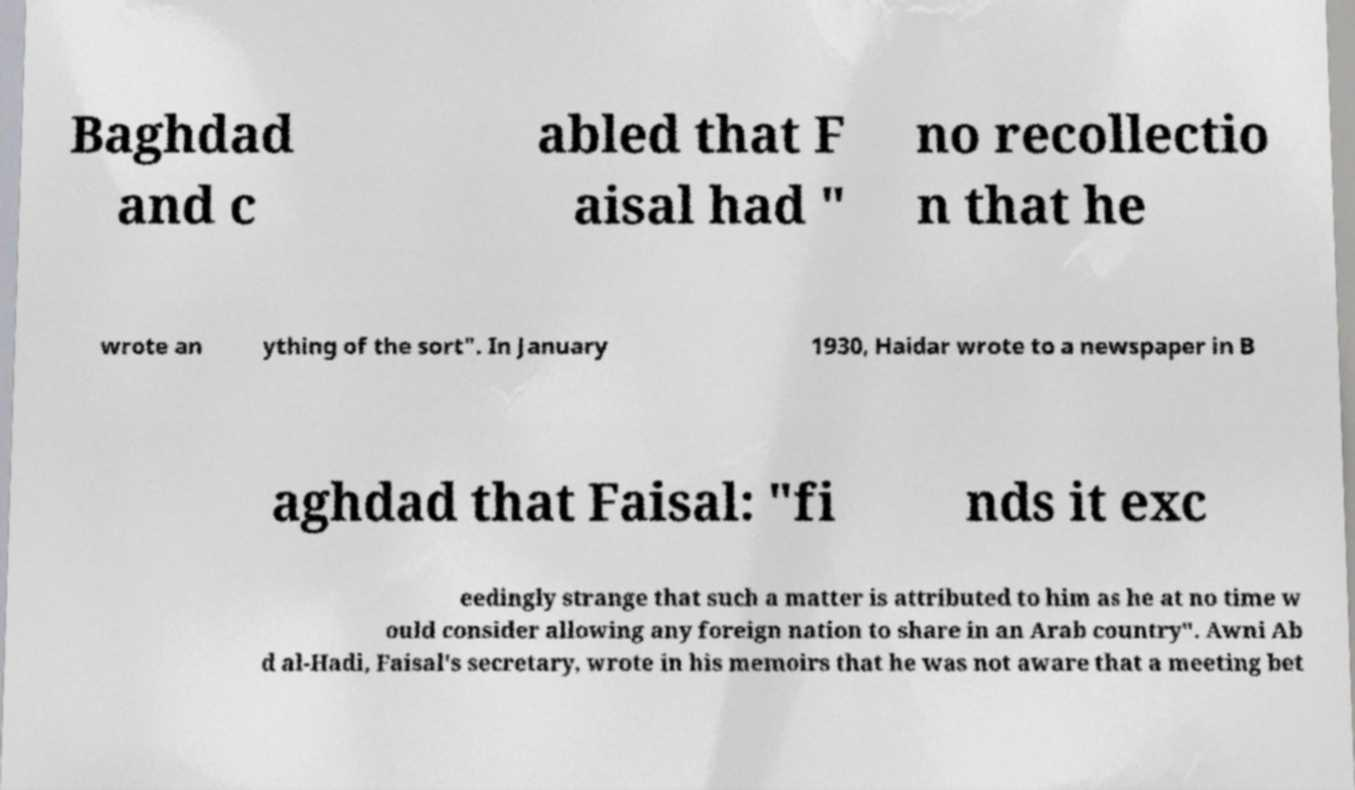Could you assist in decoding the text presented in this image and type it out clearly? Baghdad and c abled that F aisal had " no recollectio n that he wrote an ything of the sort". In January 1930, Haidar wrote to a newspaper in B aghdad that Faisal: "fi nds it exc eedingly strange that such a matter is attributed to him as he at no time w ould consider allowing any foreign nation to share in an Arab country". Awni Ab d al-Hadi, Faisal's secretary, wrote in his memoirs that he was not aware that a meeting bet 